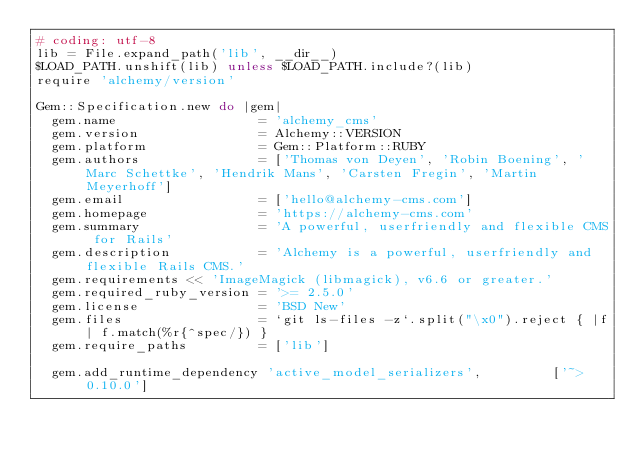<code> <loc_0><loc_0><loc_500><loc_500><_Ruby_># coding: utf-8
lib = File.expand_path('lib', __dir__)
$LOAD_PATH.unshift(lib) unless $LOAD_PATH.include?(lib)
require 'alchemy/version'

Gem::Specification.new do |gem|
  gem.name                  = 'alchemy_cms'
  gem.version               = Alchemy::VERSION
  gem.platform              = Gem::Platform::RUBY
  gem.authors               = ['Thomas von Deyen', 'Robin Boening', 'Marc Schettke', 'Hendrik Mans', 'Carsten Fregin', 'Martin Meyerhoff']
  gem.email                 = ['hello@alchemy-cms.com']
  gem.homepage              = 'https://alchemy-cms.com'
  gem.summary               = 'A powerful, userfriendly and flexible CMS for Rails'
  gem.description           = 'Alchemy is a powerful, userfriendly and flexible Rails CMS.'
  gem.requirements << 'ImageMagick (libmagick), v6.6 or greater.'
  gem.required_ruby_version = '>= 2.5.0'
  gem.license               = 'BSD New'
  gem.files                 = `git ls-files -z`.split("\x0").reject { |f| f.match(%r{^spec/}) }
  gem.require_paths         = ['lib']

  gem.add_runtime_dependency 'active_model_serializers',         ['~> 0.10.0']</code> 